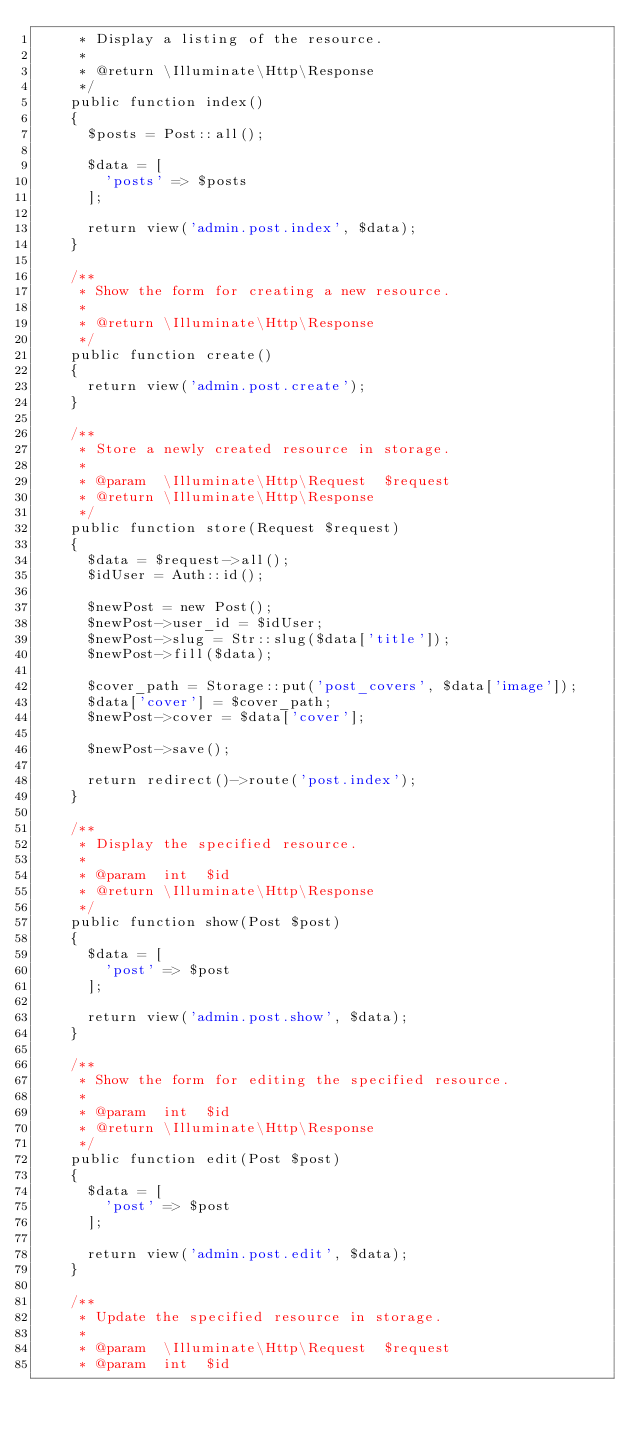<code> <loc_0><loc_0><loc_500><loc_500><_PHP_>     * Display a listing of the resource.
     *
     * @return \Illuminate\Http\Response
     */
    public function index()
    {
      $posts = Post::all();

      $data = [
        'posts' => $posts
      ];

      return view('admin.post.index', $data);
    }

    /**
     * Show the form for creating a new resource.
     *
     * @return \Illuminate\Http\Response
     */
    public function create()
    {
      return view('admin.post.create');
    }

    /**
     * Store a newly created resource in storage.
     *
     * @param  \Illuminate\Http\Request  $request
     * @return \Illuminate\Http\Response
     */
    public function store(Request $request)
    {
      $data = $request->all();
      $idUser = Auth::id();

      $newPost = new Post();
      $newPost->user_id = $idUser;
      $newPost->slug = Str::slug($data['title']);
      $newPost->fill($data);

      $cover_path = Storage::put('post_covers', $data['image']);
      $data['cover'] = $cover_path;
      $newPost->cover = $data['cover'];

      $newPost->save();

      return redirect()->route('post.index');
    }

    /**
     * Display the specified resource.
     *
     * @param  int  $id
     * @return \Illuminate\Http\Response
     */
    public function show(Post $post)
    {
      $data = [
        'post' => $post
      ];

      return view('admin.post.show', $data);
    }

    /**
     * Show the form for editing the specified resource.
     *
     * @param  int  $id
     * @return \Illuminate\Http\Response
     */
    public function edit(Post $post)
    {
      $data = [
        'post' => $post
      ];

      return view('admin.post.edit', $data);
    }

    /**
     * Update the specified resource in storage.
     *
     * @param  \Illuminate\Http\Request  $request
     * @param  int  $id</code> 